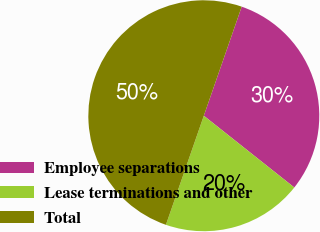Convert chart. <chart><loc_0><loc_0><loc_500><loc_500><pie_chart><fcel>Employee separations<fcel>Lease terminations and other<fcel>Total<nl><fcel>30.35%<fcel>19.65%<fcel>50.0%<nl></chart> 